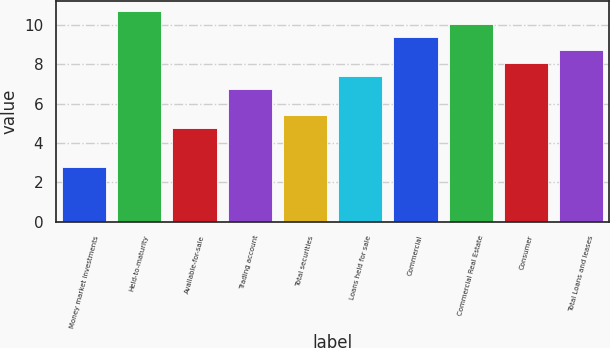<chart> <loc_0><loc_0><loc_500><loc_500><bar_chart><fcel>Money market investments<fcel>Held-to-maturity<fcel>Available-for-sale<fcel>Trading account<fcel>Total securities<fcel>Loans held for sale<fcel>Commercial<fcel>Commercial Real Estate<fcel>Consumer<fcel>Total Loans and leases<nl><fcel>2.78<fcel>10.7<fcel>4.76<fcel>6.74<fcel>5.42<fcel>7.4<fcel>9.38<fcel>10.04<fcel>8.06<fcel>8.72<nl></chart> 